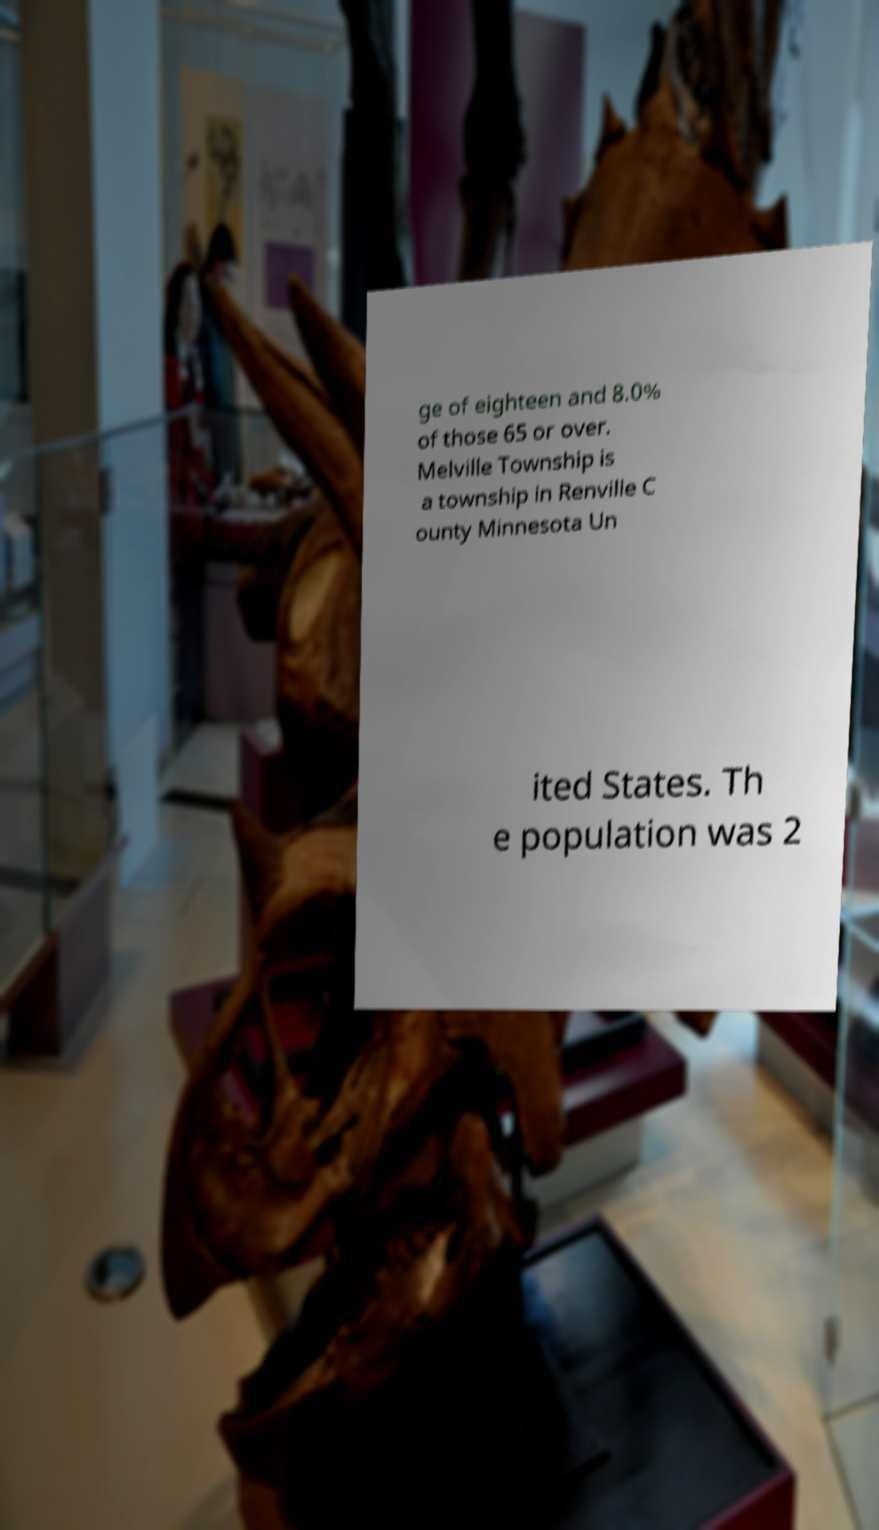Please identify and transcribe the text found in this image. ge of eighteen and 8.0% of those 65 or over. Melville Township is a township in Renville C ounty Minnesota Un ited States. Th e population was 2 